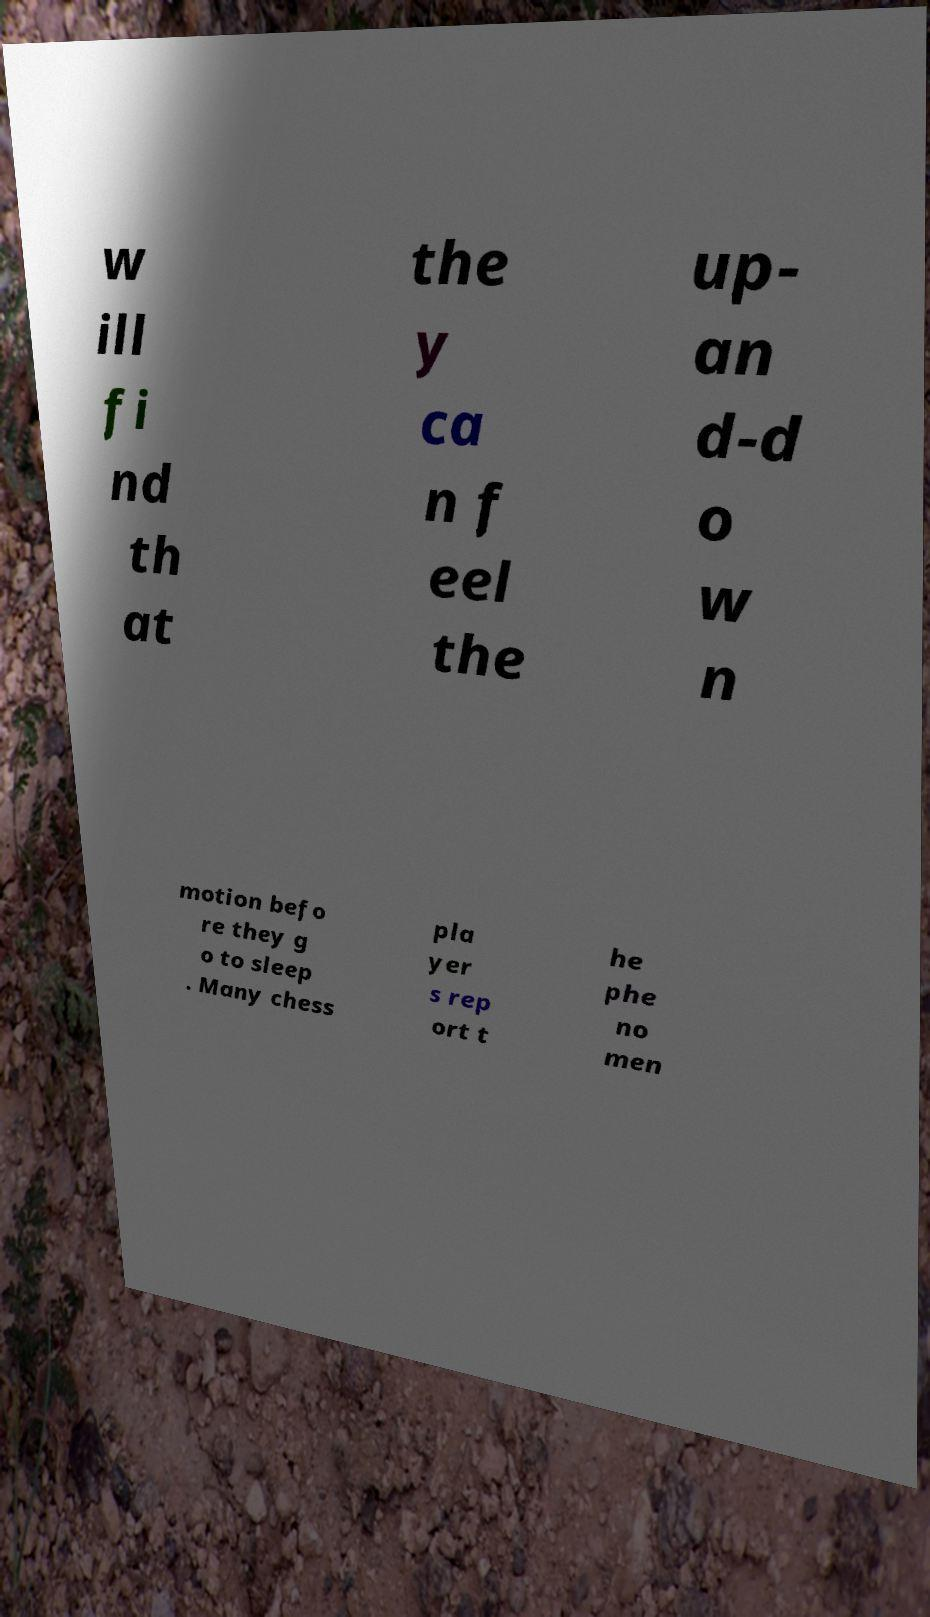What messages or text are displayed in this image? I need them in a readable, typed format. w ill fi nd th at the y ca n f eel the up- an d-d o w n motion befo re they g o to sleep . Many chess pla yer s rep ort t he phe no men 